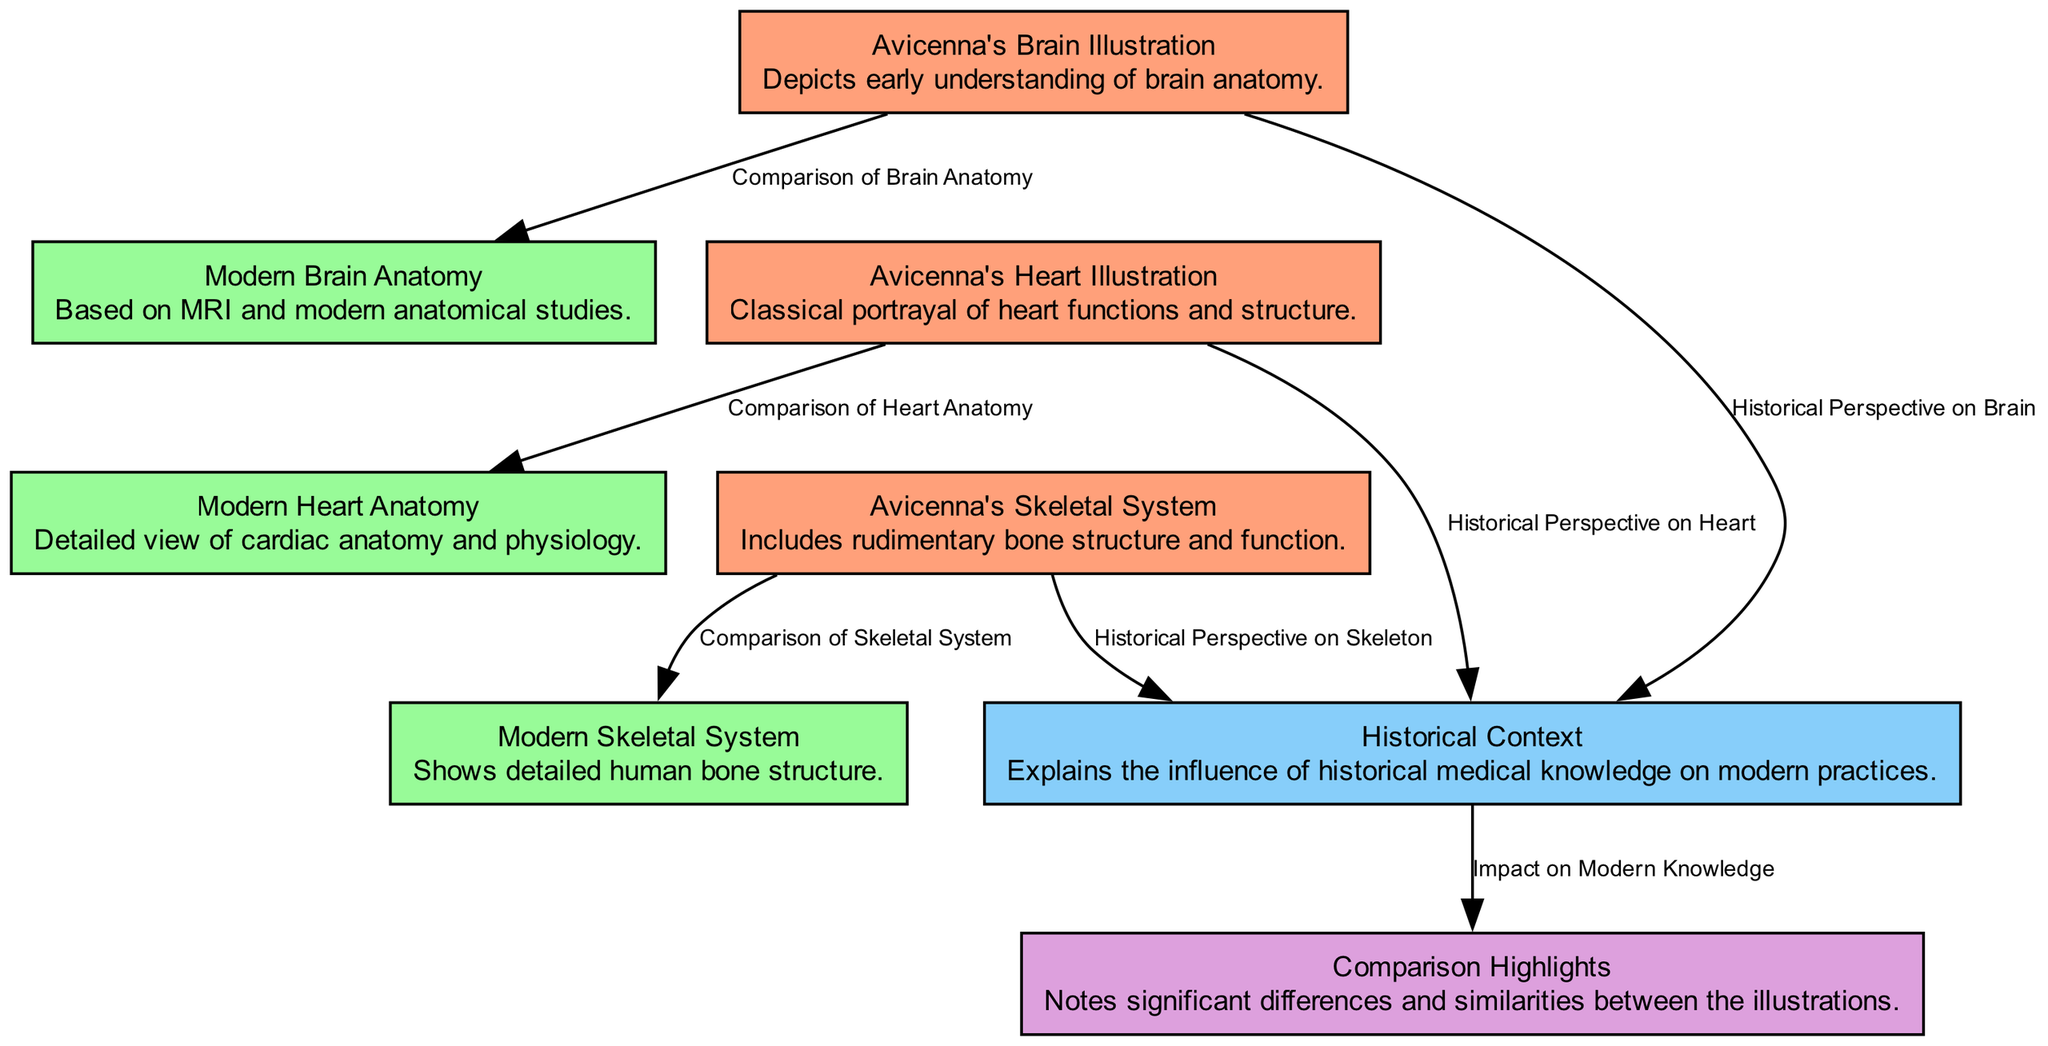What is depicted in Avicenna's brain illustration? The diagram describes that Avicenna's brain illustration depicts early understanding of brain anatomy.
Answer: early understanding of brain anatomy What color represents modern anatomy nodes? In the diagram, modern anatomical nodes are represented in pale green.
Answer: pale green How many comparisons are noted in the diagram? The diagram includes information about comparisons made, but no specific number is indicated; thus, we identify from the structure two comparisons: brain and heart.
Answer: 2 What historical context is explained in relation to the skeletal system? The diagram indicates that there is a historical perspective on the skeleton, focusing on its influence on current knowledge.
Answer: historical perspective on skeleton What comparison is made between Avicenna's heart illustration and modern anatomy? The edge 'Comparison of Heart Anatomy' indicates a comparison is made between Avicenna's heart illustration and modern heart anatomy.
Answer: Comparison of Heart Anatomy What is the general theme of the historical context node? The historical context node elaborates on the influence of historical medical knowledge on modern practices.
Answer: influence of historical medical knowledge Which illustration focuses on the brain? The node 'Avicenna's Brain Illustration' is focused specifically on the brain, indicating its importance in the diagram.
Answer: Avicenna's Brain Illustration What do the invisible edges between nodes signal? The invisible edges in the diagram are used to improve the layout and visual flow between related illustrations without showing direct comparisons.
Answer: improve layout and flow 